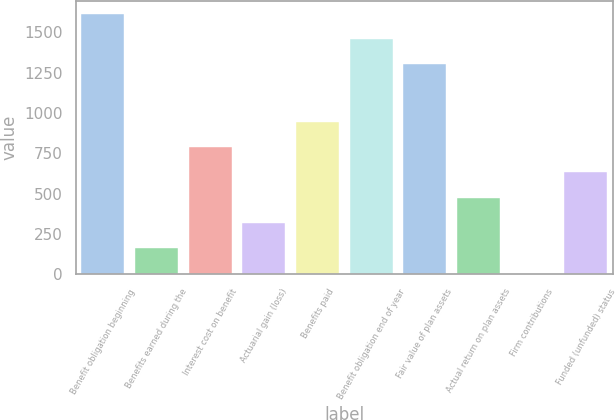<chart> <loc_0><loc_0><loc_500><loc_500><bar_chart><fcel>Benefit obligation beginning<fcel>Benefits earned during the<fcel>Interest cost on benefit<fcel>Actuarial gain (loss)<fcel>Benefits paid<fcel>Benefit obligation end of year<fcel>Fair value of plan assets<fcel>Actual return on plan assets<fcel>Firm contributions<fcel>Funded (unfunded) status<nl><fcel>1616.8<fcel>160.4<fcel>790<fcel>317.8<fcel>947.4<fcel>1459.4<fcel>1302<fcel>475.2<fcel>3<fcel>632.6<nl></chart> 